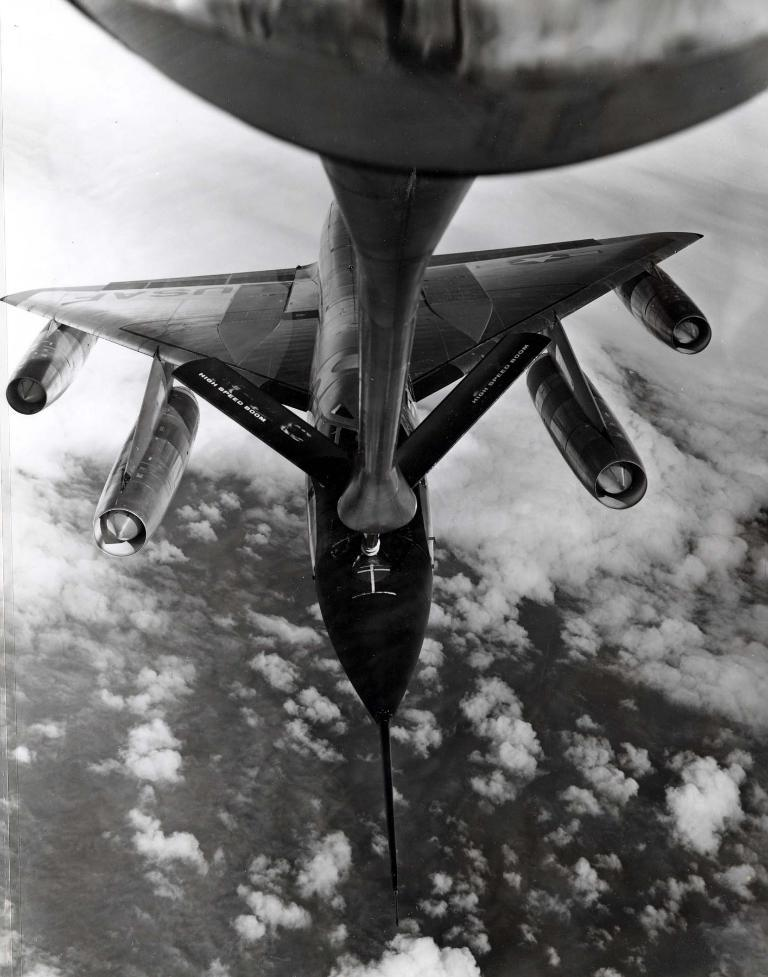What is the color scheme of the image? The image is black and white. What is the main subject of the image? There is an airplane in the image. What is the airplane doing in the image? The airplane is flying in the sky. What can be seen in the sky in the image? There are clouds visible in the image. Reasoning: Let'g: Let's think step by step in order to produce the conversation. We start by identifying the color scheme of the image, which is black and white. Then, we focus on the main subject, which is the airplane. Next, we describe the action of the airplane, which is flying in the sky. Finally, we mention the clouds visible in the sky, which adds context to the image. Absurd Question/Answer: Can you see any attention-grabbing seashore or knot in the image? There is no seashore or knot present in the image; it features a black and white image of an airplane flying in the sky with clouds visible. 